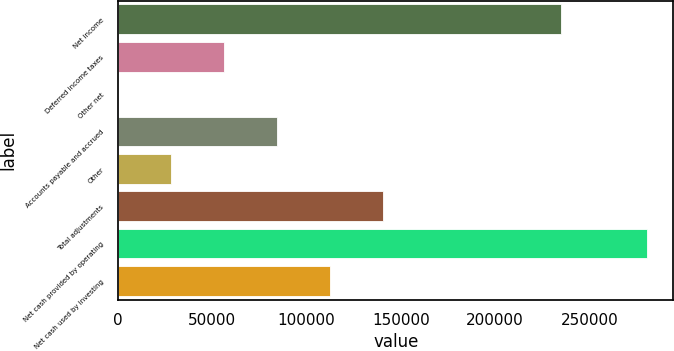<chart> <loc_0><loc_0><loc_500><loc_500><bar_chart><fcel>Net income<fcel>Deferred income taxes<fcel>Other net<fcel>Accounts payable and accrued<fcel>Other<fcel>Total adjustments<fcel>Net cash provided by operating<fcel>Net cash used by investing<nl><fcel>234916<fcel>56177.8<fcel>84<fcel>84224.7<fcel>28130.9<fcel>140318<fcel>280553<fcel>112272<nl></chart> 